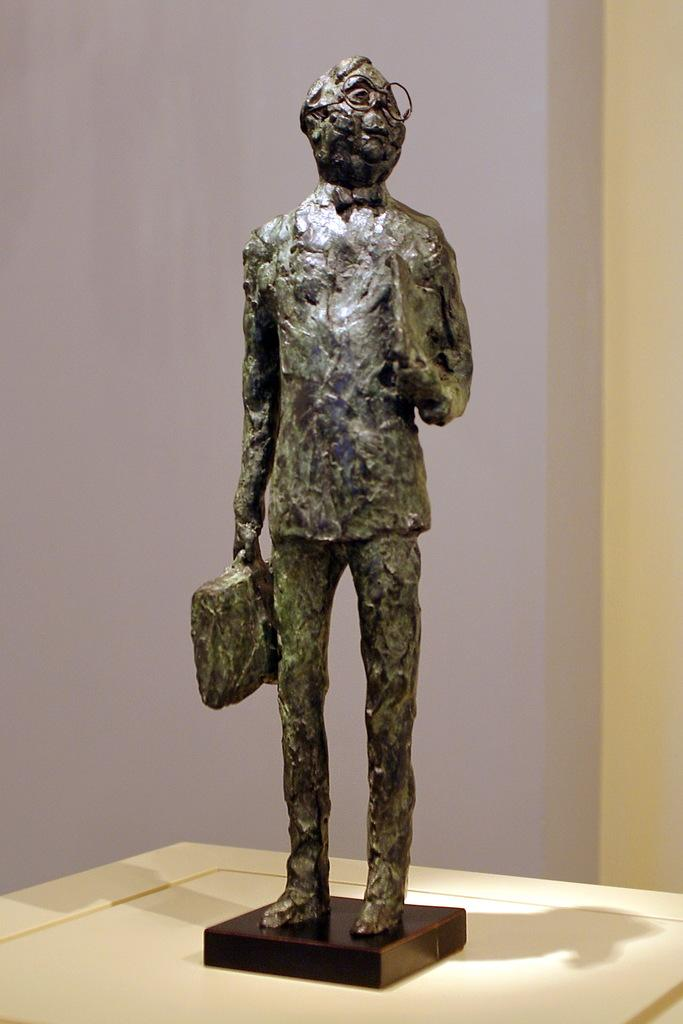What is the main subject of the image? There is a sculpture in the image. What can be seen in the background of the image? There is a wall in the background of the image. What is the relationship between the sculpture and the table in the image? There is a shadow of the sculpture on a table in the image. What type of note is attached to the sculpture in the image? There is no note attached to the sculpture in the image. What kind of waste is visible in the image? There is no waste visible in the image. Is there any evidence of a crime in the image? There is no indication of a crime in the image. 